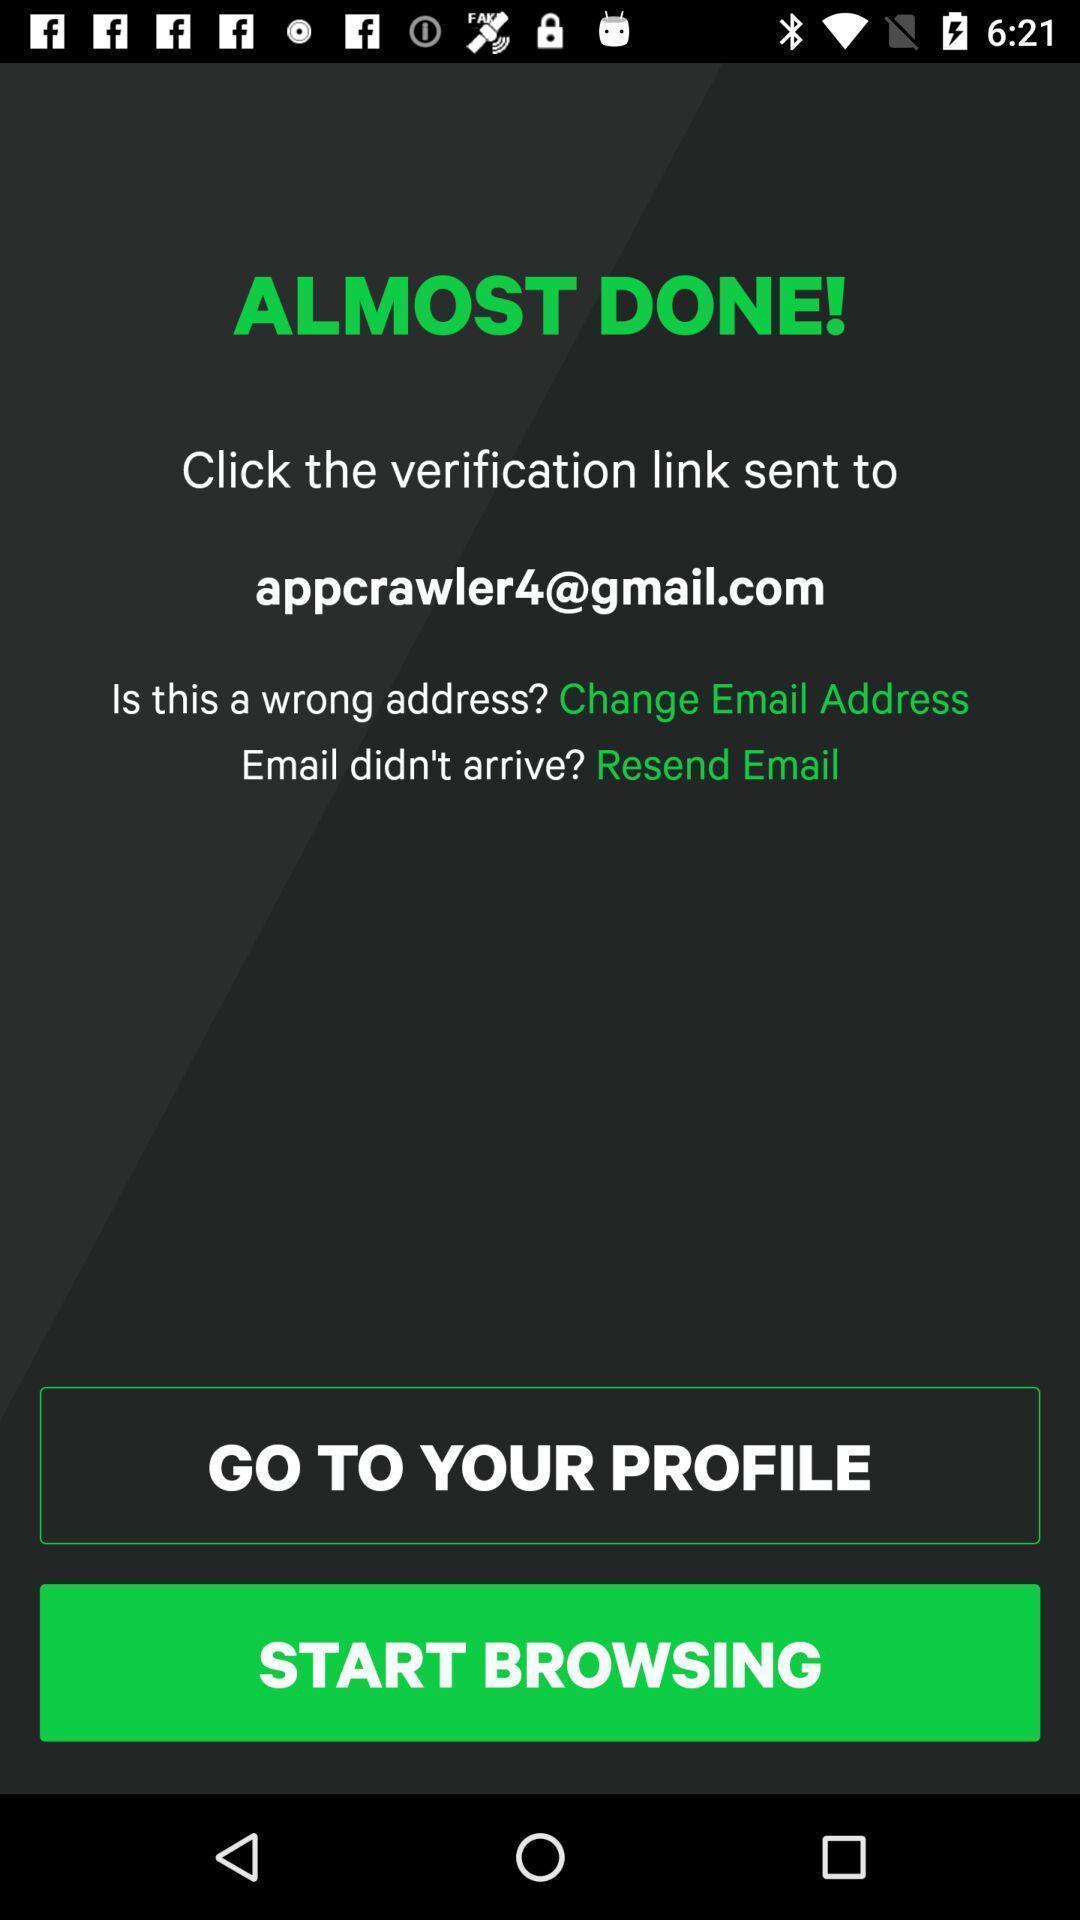Summarize the information in this screenshot. Screen displaying art gallery app. 